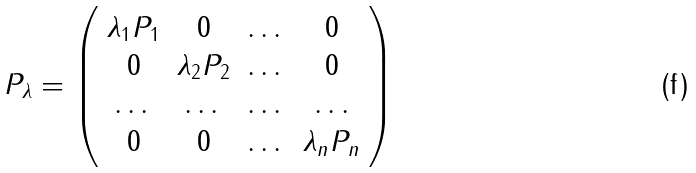<formula> <loc_0><loc_0><loc_500><loc_500>P _ { \lambda } = \left ( \begin{array} { c c c c } \lambda _ { 1 } P _ { 1 } & 0 & \dots & 0 \\ 0 & \lambda _ { 2 } P _ { 2 } & \dots & 0 \\ \dots & \dots & \dots & \dots \\ 0 & 0 & \dots & \lambda _ { n } P _ { n } \end{array} \right )</formula> 